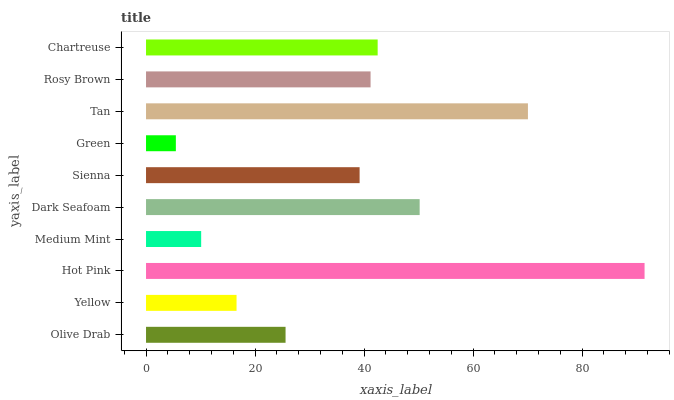Is Green the minimum?
Answer yes or no. Yes. Is Hot Pink the maximum?
Answer yes or no. Yes. Is Yellow the minimum?
Answer yes or no. No. Is Yellow the maximum?
Answer yes or no. No. Is Olive Drab greater than Yellow?
Answer yes or no. Yes. Is Yellow less than Olive Drab?
Answer yes or no. Yes. Is Yellow greater than Olive Drab?
Answer yes or no. No. Is Olive Drab less than Yellow?
Answer yes or no. No. Is Rosy Brown the high median?
Answer yes or no. Yes. Is Sienna the low median?
Answer yes or no. Yes. Is Olive Drab the high median?
Answer yes or no. No. Is Dark Seafoam the low median?
Answer yes or no. No. 